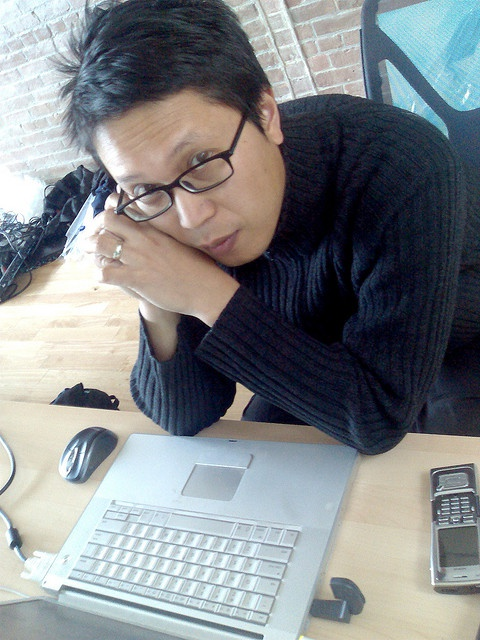Describe the objects in this image and their specific colors. I can see people in white, black, darkgray, and tan tones, laptop in white, lightblue, and darkgray tones, chair in white, lightblue, gray, and blue tones, cell phone in white, gray, darkgray, and lightgray tones, and mouse in white and gray tones in this image. 